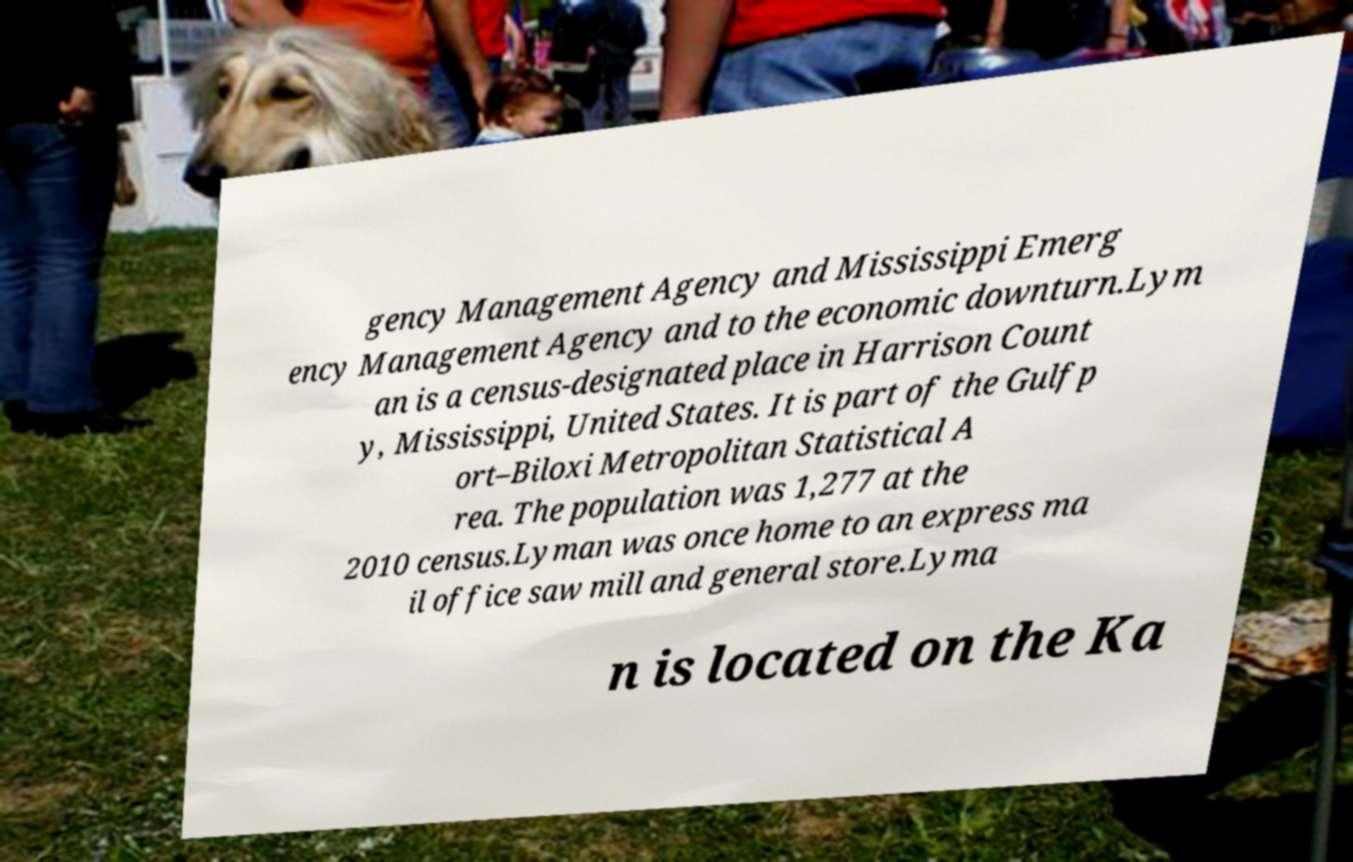For documentation purposes, I need the text within this image transcribed. Could you provide that? gency Management Agency and Mississippi Emerg ency Management Agency and to the economic downturn.Lym an is a census-designated place in Harrison Count y, Mississippi, United States. It is part of the Gulfp ort–Biloxi Metropolitan Statistical A rea. The population was 1,277 at the 2010 census.Lyman was once home to an express ma il office saw mill and general store.Lyma n is located on the Ka 